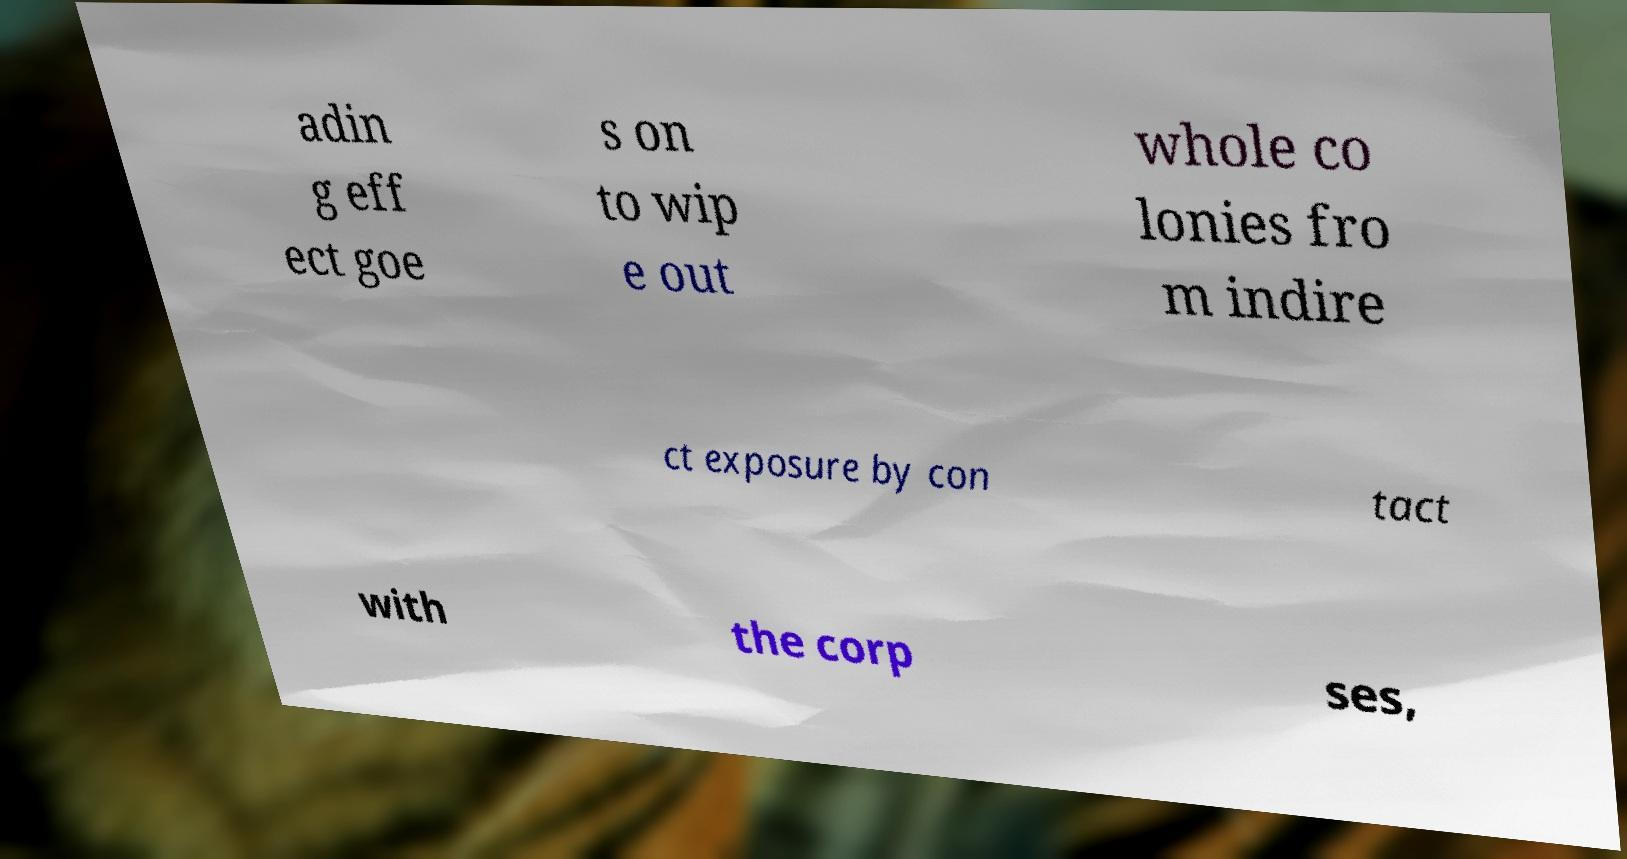Please read and relay the text visible in this image. What does it say? adin g eff ect goe s on to wip e out whole co lonies fro m indire ct exposure by con tact with the corp ses, 